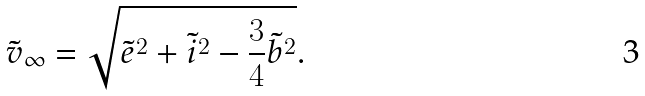Convert formula to latex. <formula><loc_0><loc_0><loc_500><loc_500>\tilde { v } _ { \infty } = \sqrt { \tilde { e } ^ { 2 } + \tilde { i } ^ { 2 } - \frac { 3 } { 4 } \tilde { b } ^ { 2 } } .</formula> 